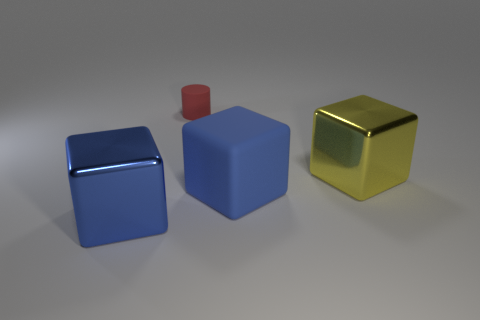There is a thing that is both behind the blue matte thing and in front of the red matte cylinder; what shape is it?
Ensure brevity in your answer.  Cube. What number of metal objects have the same shape as the blue rubber object?
Give a very brief answer. 2. What number of large gray metallic cylinders are there?
Ensure brevity in your answer.  0. How big is the cube that is both in front of the big yellow thing and to the right of the red rubber cylinder?
Provide a succinct answer. Large. What is the shape of the rubber thing that is the same size as the yellow block?
Give a very brief answer. Cube. There is a blue cube that is left of the rubber cylinder; are there any blue shiny blocks behind it?
Your answer should be compact. No. What is the color of the rubber thing that is the same shape as the yellow metallic thing?
Offer a terse response. Blue. There is a big metallic cube on the left side of the red cylinder; is it the same color as the small object?
Provide a succinct answer. No. How many things are big yellow metallic blocks in front of the red rubber object or big cyan rubber cylinders?
Offer a very short reply. 1. The big blue cube that is right of the object in front of the blue object on the right side of the cylinder is made of what material?
Offer a very short reply. Rubber. 